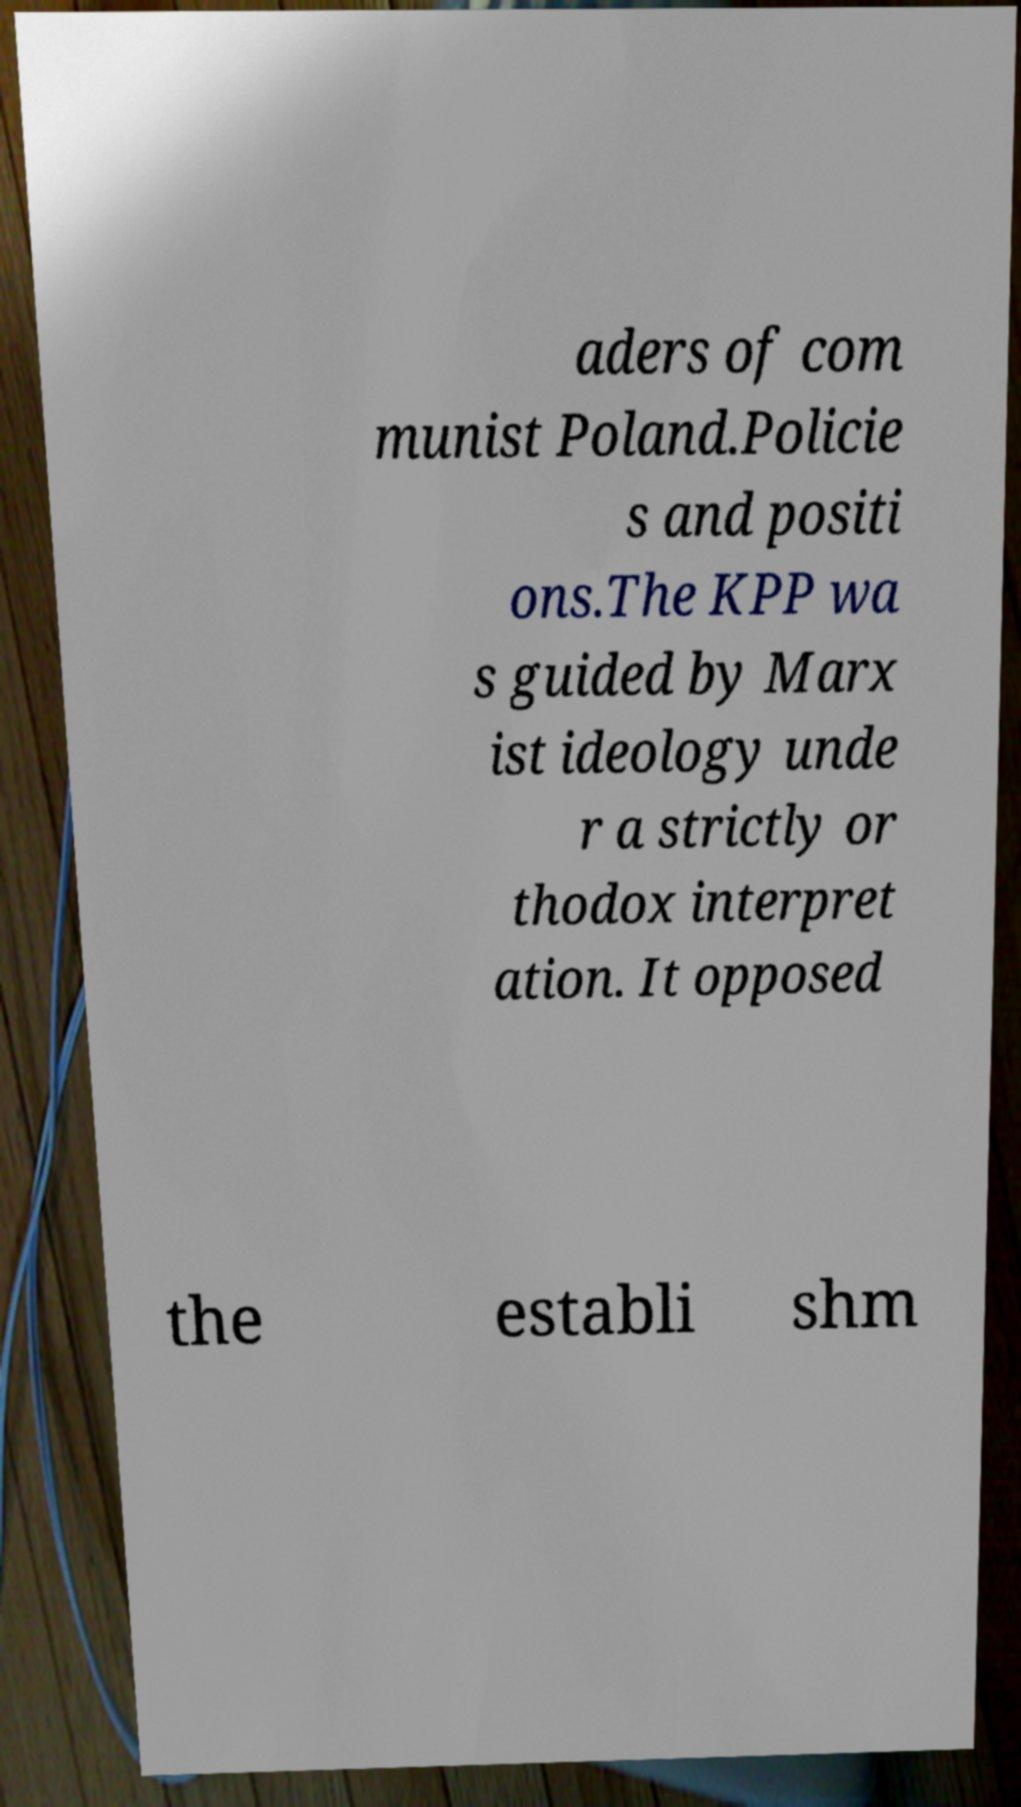Could you assist in decoding the text presented in this image and type it out clearly? aders of com munist Poland.Policie s and positi ons.The KPP wa s guided by Marx ist ideology unde r a strictly or thodox interpret ation. It opposed the establi shm 